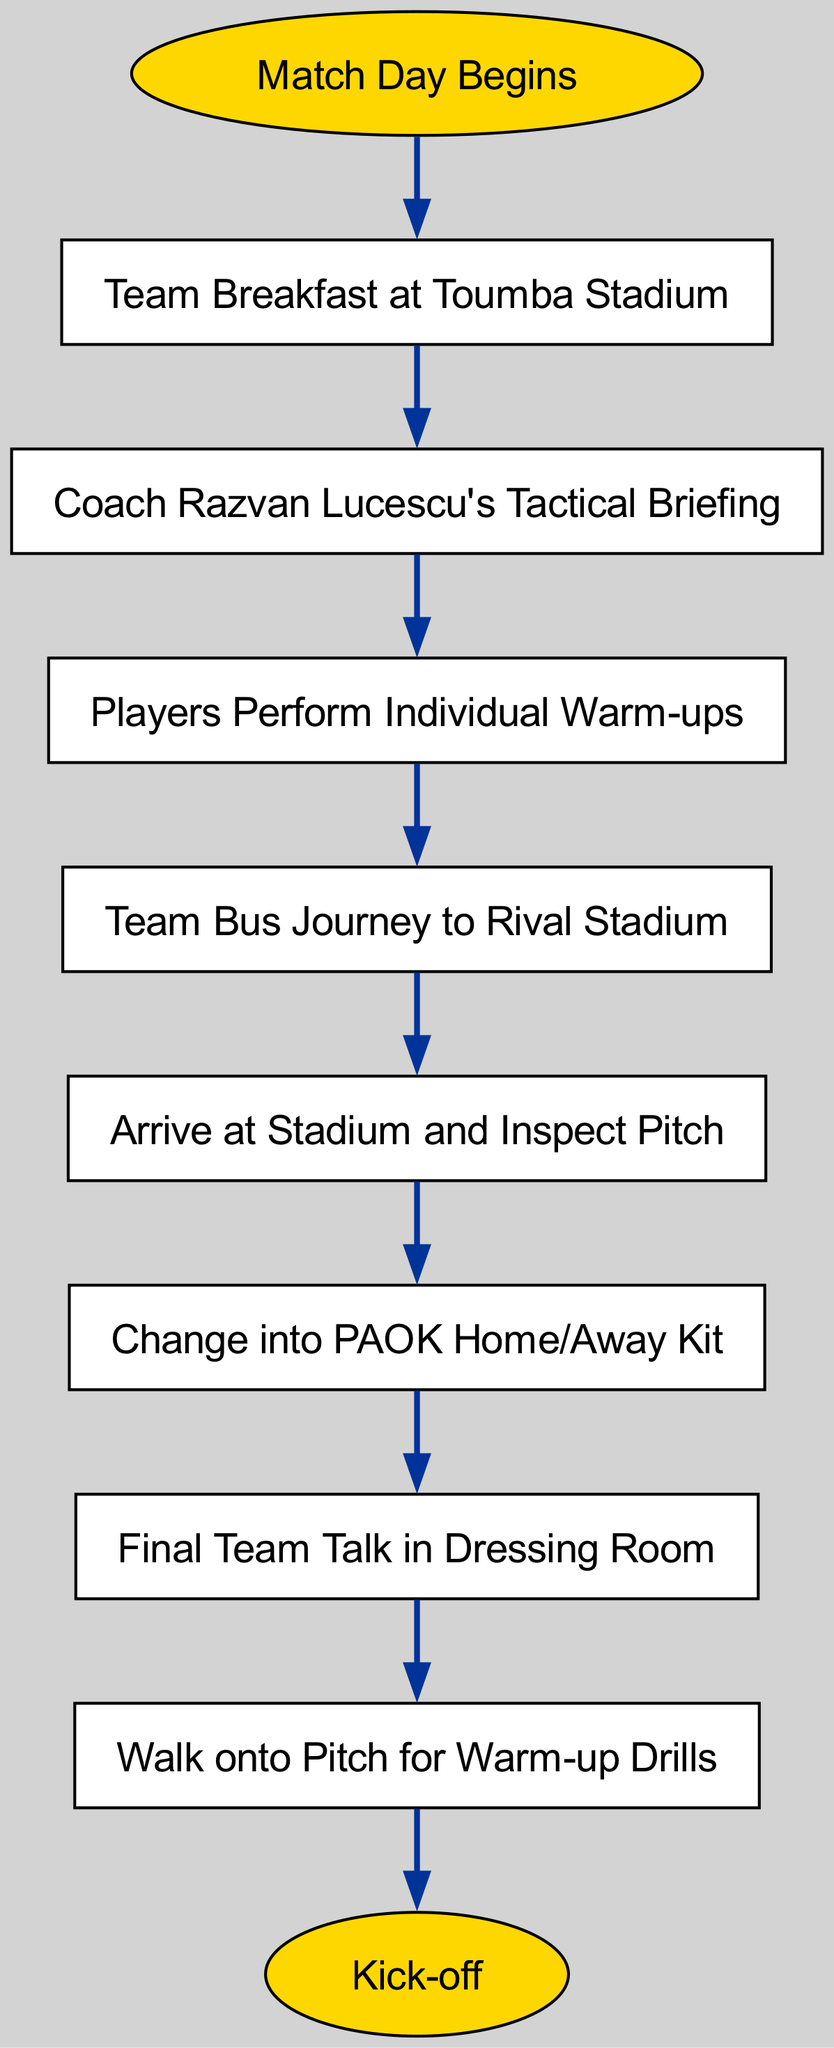What is the first step in the match day preparation process? The first step is represented by the "Match Day Begins" node. The diagram clearly starts from this node, leading into the first action of team breakfast.
Answer: Team Breakfast at Toumba Stadium How many steps are there in the match day preparation process? Counting the nodes in the flow from the beginning to the end, there are eight steps including the initial step and the end.
Answer: Eight What is the last action before kick-off? The diagram flows through the nodes from the start to the end, with the final action before kick-off being "Walk onto Pitch for Warm-up Drills."
Answer: Walk onto Pitch for Warm-up Drills Which step involves the coach? The diagram shows a step where the coach is mentioned specifically, which is "Coach Razvan Lucescu's Tactical Briefing." This step is directly after the team breakfast.
Answer: Coach Razvan Lucescu's Tactical Briefing What action follows "Change into PAOK Home/Away Kit"? The flow of the diagram indicates that after changing into the kit, the next action is "Final Team Talk in Dressing Room." This can be identified by following the arrows in the flow chart.
Answer: Final Team Talk in Dressing Room What is the last node in the diagram? The last node as indicated in the flow chart is the "Kick-off" node, which follows the entire preparation process leading up to it.
Answer: Kick-off Which action comes after "Players Perform Individual Warm-ups"? According to the flow of the diagram, the action that comes directly after the individual warm-ups is "Team Bus Journey to Rival Stadium."
Answer: Team Bus Journey to Rival Stadium How is the starting point represented in the diagram? The starting point is represented by an oval shape called "Match Day Begins," which is visually distinct from the rectangular steps that follow.
Answer: Match Day Begins Which step is directly before "Arrive at Stadium and Inspect Pitch"? The step that directly precedes arriving at the stadium is "Team Bus Journey to Rival Stadium." This can be traced back through the flow of the chart.
Answer: Team Bus Journey to Rival Stadium 